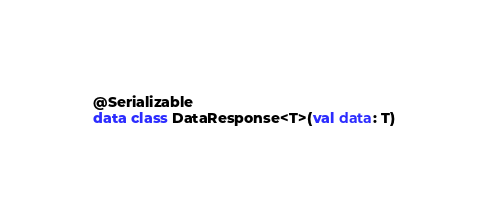<code> <loc_0><loc_0><loc_500><loc_500><_Kotlin_>
@Serializable
data class DataResponse<T>(val data: T)
</code> 